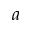Convert formula to latex. <formula><loc_0><loc_0><loc_500><loc_500>a</formula> 